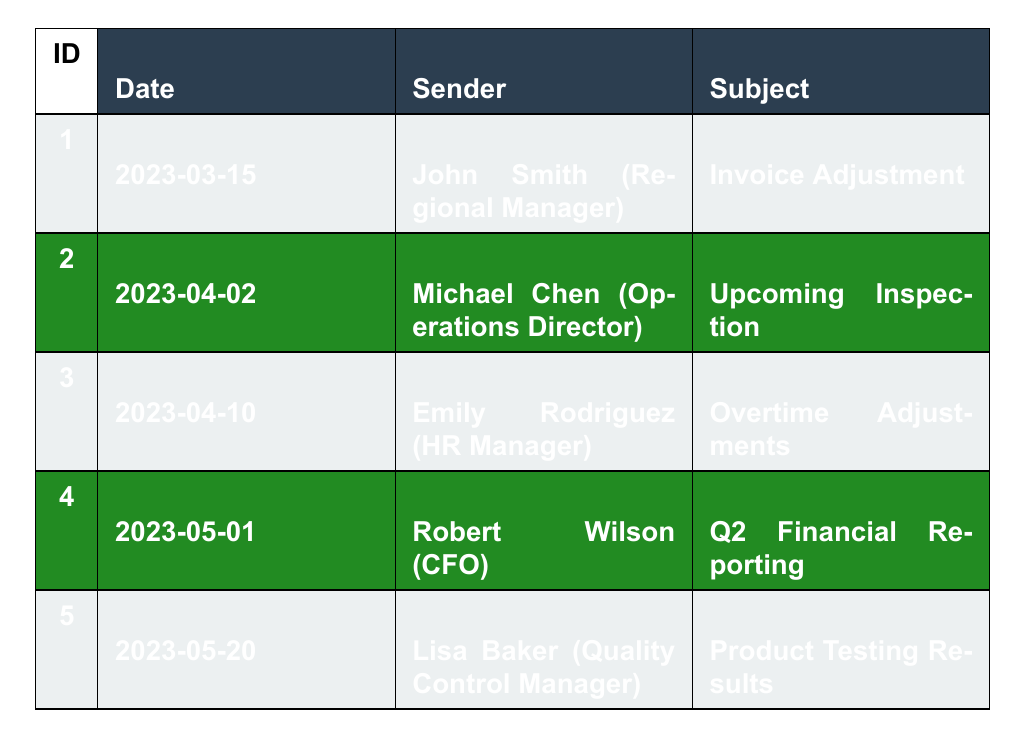What is the subject of the communication sent by John Smith? The subject of John's communication is listed in the table under the "Subject" column for his entry, which is "Invoice Adjustment."
Answer: Invoice Adjustment How many communication records were sent in April 2023? There are two records in the table with dates in April 2023: one from Michael Chen on April 2 and another from Emily Rodriguez on April 10.
Answer: 2 Who was the recipient of the email regarding "Product Testing Results"? According to the table, the recipient of the "Product Testing Results" communication is Lisa Baker, who sent it to the Production Supervisors.
Answer: Production Supervisors Was any communication regarding illegal activities captured in this table? Based on the content of the communication records, there are questionable practices discussed, but none explicitly mention illegal activities. Thus, the answer is no.
Answer: No What is the difference in the number of records between March and May 2023? There is one record from March (1) and one from May (1), totaling two records in May. The difference is 1 - 1 = 0.
Answer: 0 What position is Michael Chen in? Michael Chen is listed as the Operations Director in the table for his communication entry.
Answer: Operations Director Which communication suggests action that may violate labor laws? The communication from Emily Rodriguez on April 10 suggests classifying excess overtime hours as 'training time' to avoid labor law issues, indicating a potential violation.
Answer: Emily Rodriguez's communication In how many instances is the CFO involved in the communications? The table shows that the CFO, Robert Wilson, is involved in one instance of communication concerning Q2 financial reporting.
Answer: 1 What topic did Robert Wilson address in his communication? Robert Wilson addressed topics related to Q2 financial reporting, specifically the distribution of 'consulting fees' to minimize scrutiny.
Answer: Q2 financial reporting If all communications listed were about trimming costs, how many correspondences indicate cost-cutting measures? The communications from John Smith and Robert Wilson involve potential cost-cutting measures by removing fees and distributing expenses differently, totaling two instances.
Answer: 2 